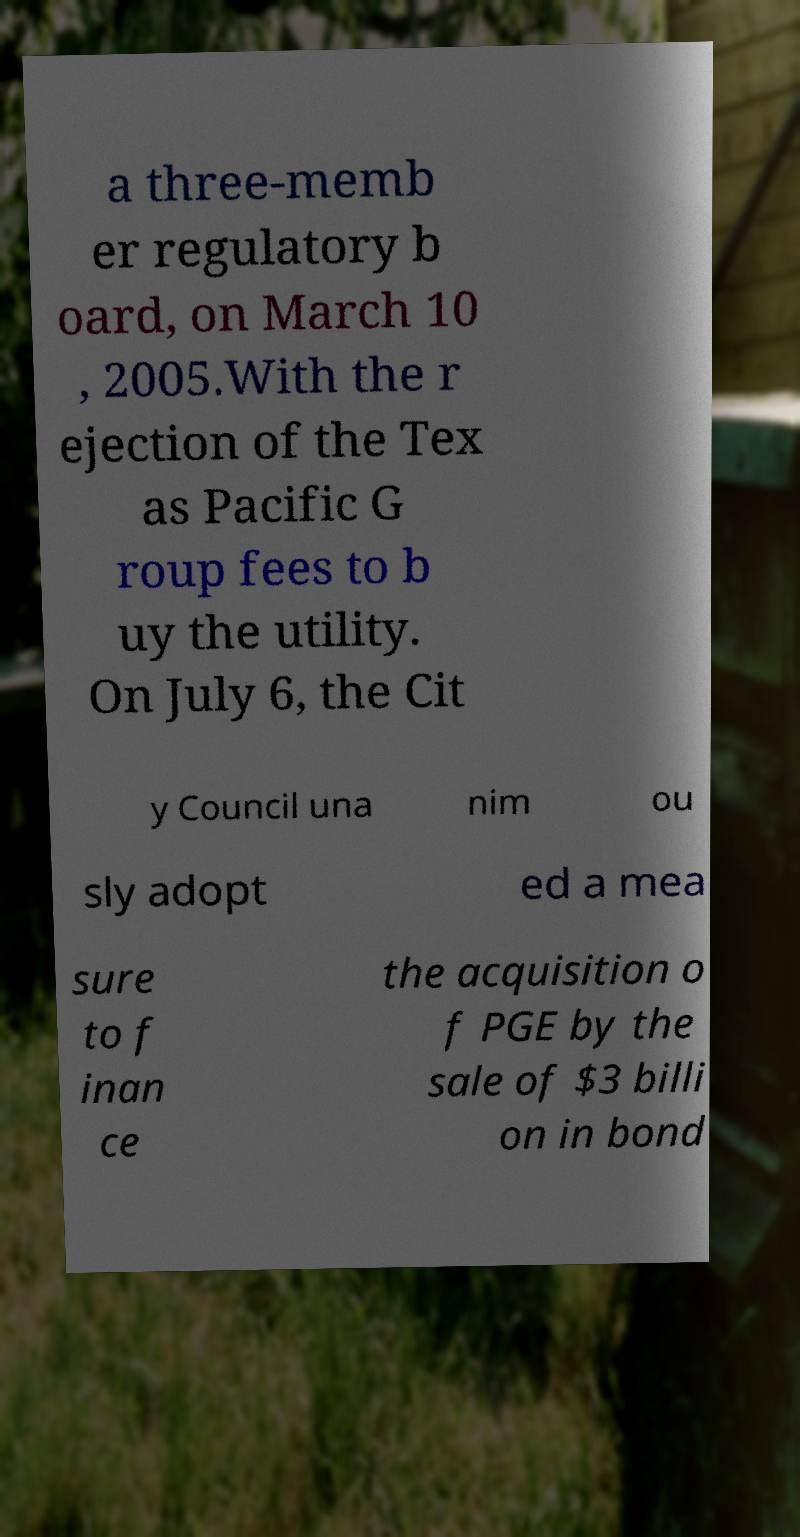For documentation purposes, I need the text within this image transcribed. Could you provide that? a three-memb er regulatory b oard, on March 10 , 2005.With the r ejection of the Tex as Pacific G roup fees to b uy the utility. On July 6, the Cit y Council una nim ou sly adopt ed a mea sure to f inan ce the acquisition o f PGE by the sale of $3 billi on in bond 